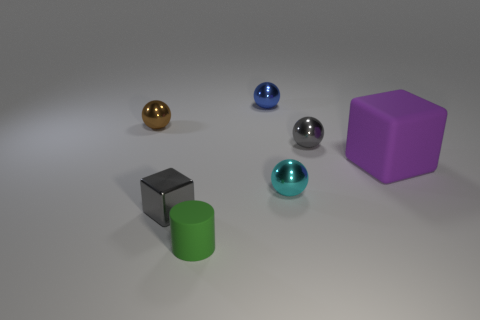If this image was part of a story, what do you think could be happening? If this image was part of a story, it could be a scene from a futuristic or high-tech narrative. The collection of geometric shapes could represent various devices, gadgets, or data storage modules. The different colors might signify different functions or energy types within the narrative's technology system. 